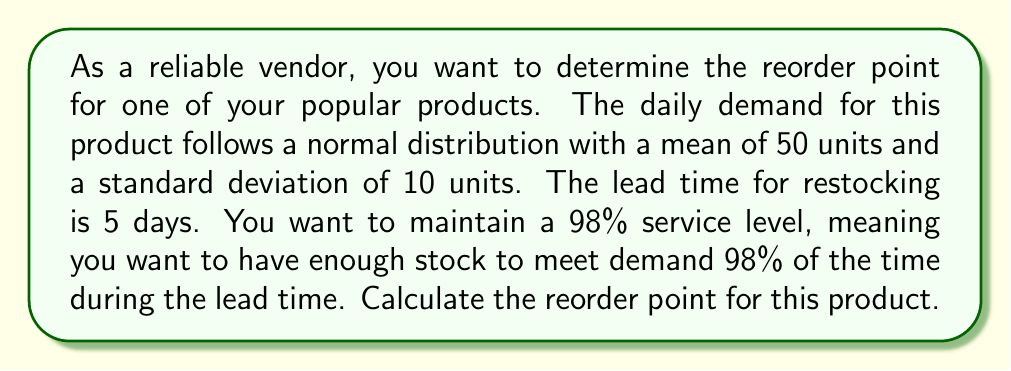Give your solution to this math problem. To determine the reorder point, we need to follow these steps:

1) First, we need to calculate the mean demand during the lead time:
   $$ \mu_{LT} = \text{Daily mean} \times \text{Lead time} = 50 \times 5 = 250 \text{ units} $$

2) Next, we calculate the standard deviation of demand during the lead time:
   $$ \sigma_{LT} = \sigma_{\text{daily}} \times \sqrt{\text{Lead time}} = 10 \times \sqrt{5} \approx 22.36 \text{ units} $$

3) For a 98% service level, we need to find the z-score that corresponds to a right-tail probability of 0.02 (1 - 0.98). Using a standard normal distribution table or calculator, we find:
   $$ z_{0.98} \approx 2.05 $$

4) The reorder point (ROP) is then calculated as:
   $$ ROP = \mu_{LT} + z_{0.98} \times \sigma_{LT} $$

5) Substituting our values:
   $$ ROP = 250 + 2.05 \times 22.36 \approx 295.84 \text{ units} $$

6) Since we can't order fractional units, we round up to the nearest whole number:
   $$ ROP = 296 \text{ units} $$

This means that when the inventory level drops to 296 units, a new order should be placed to replenish the stock.
Answer: The reorder point is 296 units. 